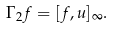<formula> <loc_0><loc_0><loc_500><loc_500>\Gamma _ { 2 } f = [ f , u ] _ { \infty } .</formula> 